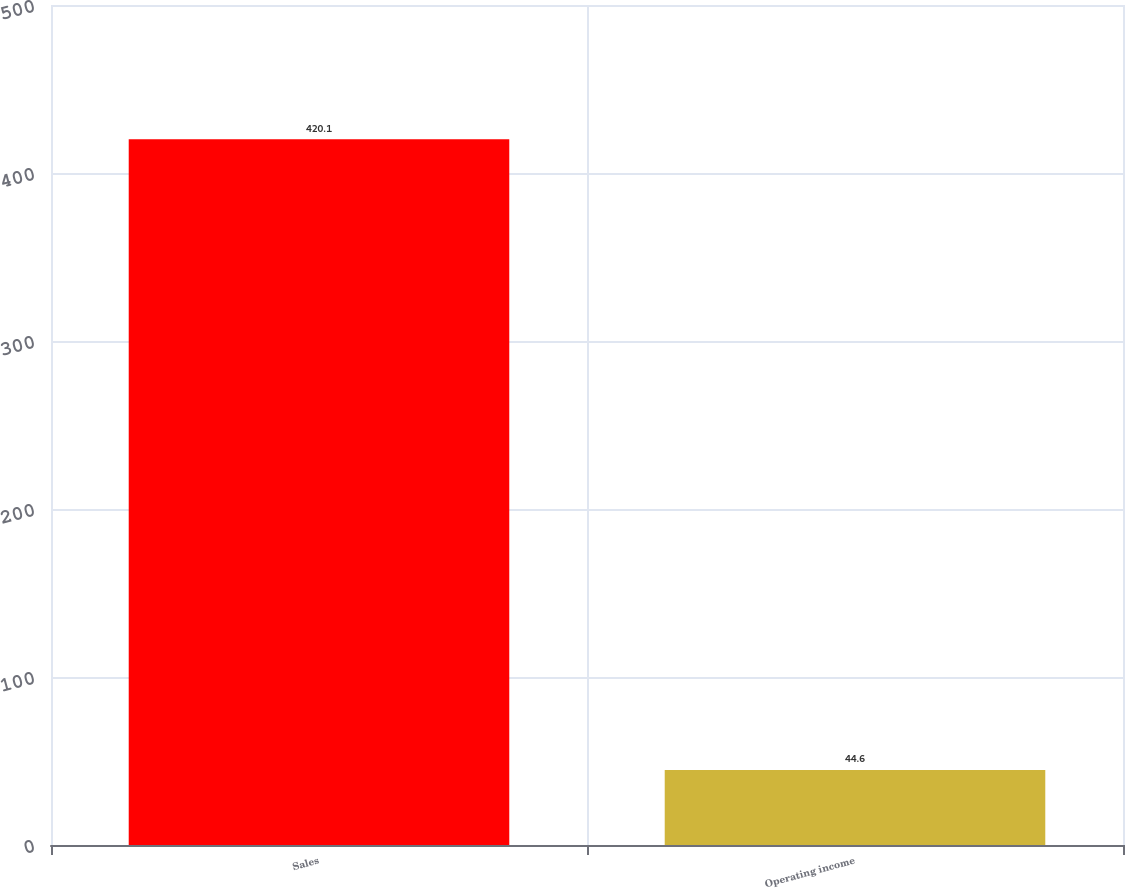Convert chart. <chart><loc_0><loc_0><loc_500><loc_500><bar_chart><fcel>Sales<fcel>Operating income<nl><fcel>420.1<fcel>44.6<nl></chart> 